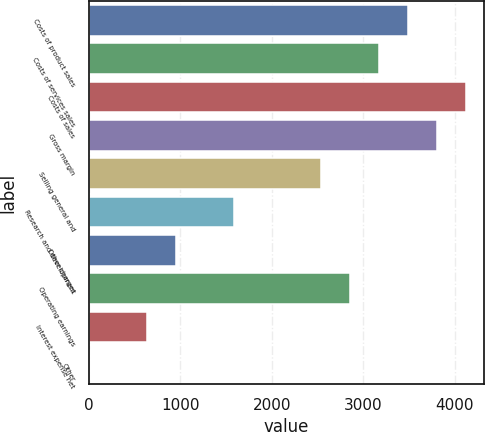<chart> <loc_0><loc_0><loc_500><loc_500><bar_chart><fcel>Costs of product sales<fcel>Costs of services sales<fcel>Costs of sales<fcel>Gross margin<fcel>Selling general and<fcel>Research and development<fcel>Other charges<fcel>Operating earnings<fcel>Interest expense net<fcel>Other<nl><fcel>3485.2<fcel>3169<fcel>4117.6<fcel>3801.4<fcel>2536.6<fcel>1588<fcel>955.6<fcel>2852.8<fcel>639.4<fcel>7<nl></chart> 